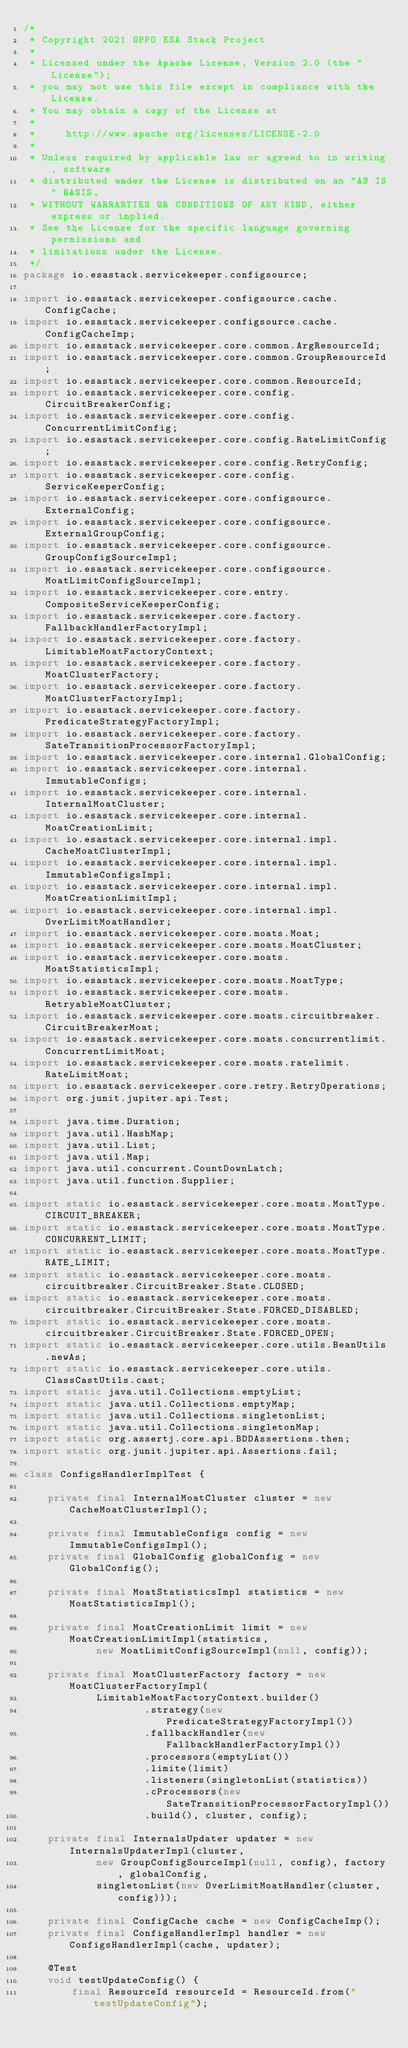<code> <loc_0><loc_0><loc_500><loc_500><_Java_>/*
 * Copyright 2021 OPPO ESA Stack Project
 *
 * Licensed under the Apache License, Version 2.0 (the "License");
 * you may not use this file except in compliance with the License.
 * You may obtain a copy of the License at
 *
 *     http://www.apache.org/licenses/LICENSE-2.0
 *
 * Unless required by applicable law or agreed to in writing, software
 * distributed under the License is distributed on an "AS IS" BASIS,
 * WITHOUT WARRANTIES OR CONDITIONS OF ANY KIND, either express or implied.
 * See the License for the specific language governing permissions and
 * limitations under the License.
 */
package io.esastack.servicekeeper.configsource;

import io.esastack.servicekeeper.configsource.cache.ConfigCache;
import io.esastack.servicekeeper.configsource.cache.ConfigCacheImp;
import io.esastack.servicekeeper.core.common.ArgResourceId;
import io.esastack.servicekeeper.core.common.GroupResourceId;
import io.esastack.servicekeeper.core.common.ResourceId;
import io.esastack.servicekeeper.core.config.CircuitBreakerConfig;
import io.esastack.servicekeeper.core.config.ConcurrentLimitConfig;
import io.esastack.servicekeeper.core.config.RateLimitConfig;
import io.esastack.servicekeeper.core.config.RetryConfig;
import io.esastack.servicekeeper.core.config.ServiceKeeperConfig;
import io.esastack.servicekeeper.core.configsource.ExternalConfig;
import io.esastack.servicekeeper.core.configsource.ExternalGroupConfig;
import io.esastack.servicekeeper.core.configsource.GroupConfigSourceImpl;
import io.esastack.servicekeeper.core.configsource.MoatLimitConfigSourceImpl;
import io.esastack.servicekeeper.core.entry.CompositeServiceKeeperConfig;
import io.esastack.servicekeeper.core.factory.FallbackHandlerFactoryImpl;
import io.esastack.servicekeeper.core.factory.LimitableMoatFactoryContext;
import io.esastack.servicekeeper.core.factory.MoatClusterFactory;
import io.esastack.servicekeeper.core.factory.MoatClusterFactoryImpl;
import io.esastack.servicekeeper.core.factory.PredicateStrategyFactoryImpl;
import io.esastack.servicekeeper.core.factory.SateTransitionProcessorFactoryImpl;
import io.esastack.servicekeeper.core.internal.GlobalConfig;
import io.esastack.servicekeeper.core.internal.ImmutableConfigs;
import io.esastack.servicekeeper.core.internal.InternalMoatCluster;
import io.esastack.servicekeeper.core.internal.MoatCreationLimit;
import io.esastack.servicekeeper.core.internal.impl.CacheMoatClusterImpl;
import io.esastack.servicekeeper.core.internal.impl.ImmutableConfigsImpl;
import io.esastack.servicekeeper.core.internal.impl.MoatCreationLimitImpl;
import io.esastack.servicekeeper.core.internal.impl.OverLimitMoatHandler;
import io.esastack.servicekeeper.core.moats.Moat;
import io.esastack.servicekeeper.core.moats.MoatCluster;
import io.esastack.servicekeeper.core.moats.MoatStatisticsImpl;
import io.esastack.servicekeeper.core.moats.MoatType;
import io.esastack.servicekeeper.core.moats.RetryableMoatCluster;
import io.esastack.servicekeeper.core.moats.circuitbreaker.CircuitBreakerMoat;
import io.esastack.servicekeeper.core.moats.concurrentlimit.ConcurrentLimitMoat;
import io.esastack.servicekeeper.core.moats.ratelimit.RateLimitMoat;
import io.esastack.servicekeeper.core.retry.RetryOperations;
import org.junit.jupiter.api.Test;

import java.time.Duration;
import java.util.HashMap;
import java.util.List;
import java.util.Map;
import java.util.concurrent.CountDownLatch;
import java.util.function.Supplier;

import static io.esastack.servicekeeper.core.moats.MoatType.CIRCUIT_BREAKER;
import static io.esastack.servicekeeper.core.moats.MoatType.CONCURRENT_LIMIT;
import static io.esastack.servicekeeper.core.moats.MoatType.RATE_LIMIT;
import static io.esastack.servicekeeper.core.moats.circuitbreaker.CircuitBreaker.State.CLOSED;
import static io.esastack.servicekeeper.core.moats.circuitbreaker.CircuitBreaker.State.FORCED_DISABLED;
import static io.esastack.servicekeeper.core.moats.circuitbreaker.CircuitBreaker.State.FORCED_OPEN;
import static io.esastack.servicekeeper.core.utils.BeanUtils.newAs;
import static io.esastack.servicekeeper.core.utils.ClassCastUtils.cast;
import static java.util.Collections.emptyList;
import static java.util.Collections.emptyMap;
import static java.util.Collections.singletonList;
import static java.util.Collections.singletonMap;
import static org.assertj.core.api.BDDAssertions.then;
import static org.junit.jupiter.api.Assertions.fail;

class ConfigsHandlerImplTest {

    private final InternalMoatCluster cluster = new CacheMoatClusterImpl();

    private final ImmutableConfigs config = new ImmutableConfigsImpl();
    private final GlobalConfig globalConfig = new GlobalConfig();

    private final MoatStatisticsImpl statistics = new MoatStatisticsImpl();

    private final MoatCreationLimit limit = new MoatCreationLimitImpl(statistics,
            new MoatLimitConfigSourceImpl(null, config));

    private final MoatClusterFactory factory = new MoatClusterFactoryImpl(
            LimitableMoatFactoryContext.builder()
                    .strategy(new PredicateStrategyFactoryImpl())
                    .fallbackHandler(new FallbackHandlerFactoryImpl())
                    .processors(emptyList())
                    .limite(limit)
                    .listeners(singletonList(statistics))
                    .cProcessors(new SateTransitionProcessorFactoryImpl())
                    .build(), cluster, config);

    private final InternalsUpdater updater = new InternalsUpdaterImpl(cluster,
            new GroupConfigSourceImpl(null, config), factory, globalConfig,
            singletonList(new OverLimitMoatHandler(cluster, config)));

    private final ConfigCache cache = new ConfigCacheImp();
    private final ConfigsHandlerImpl handler = new ConfigsHandlerImpl(cache, updater);

    @Test
    void testUpdateConfig() {
        final ResourceId resourceId = ResourceId.from("testUpdateConfig");</code> 